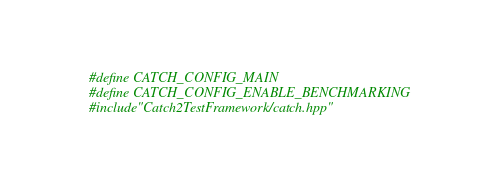<code> <loc_0><loc_0><loc_500><loc_500><_C++_>#define CATCH_CONFIG_MAIN
#define CATCH_CONFIG_ENABLE_BENCHMARKING
#include"Catch2TestFramework/catch.hpp"
</code> 